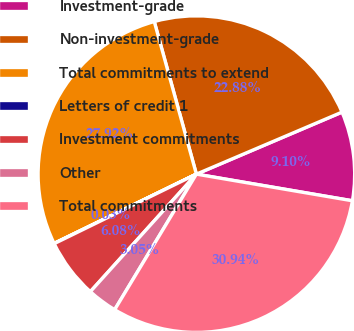Convert chart to OTSL. <chart><loc_0><loc_0><loc_500><loc_500><pie_chart><fcel>Investment-grade<fcel>Non-investment-grade<fcel>Total commitments to extend<fcel>Letters of credit 1<fcel>Investment commitments<fcel>Other<fcel>Total commitments<nl><fcel>9.1%<fcel>22.88%<fcel>27.92%<fcel>0.03%<fcel>6.08%<fcel>3.05%<fcel>30.94%<nl></chart> 